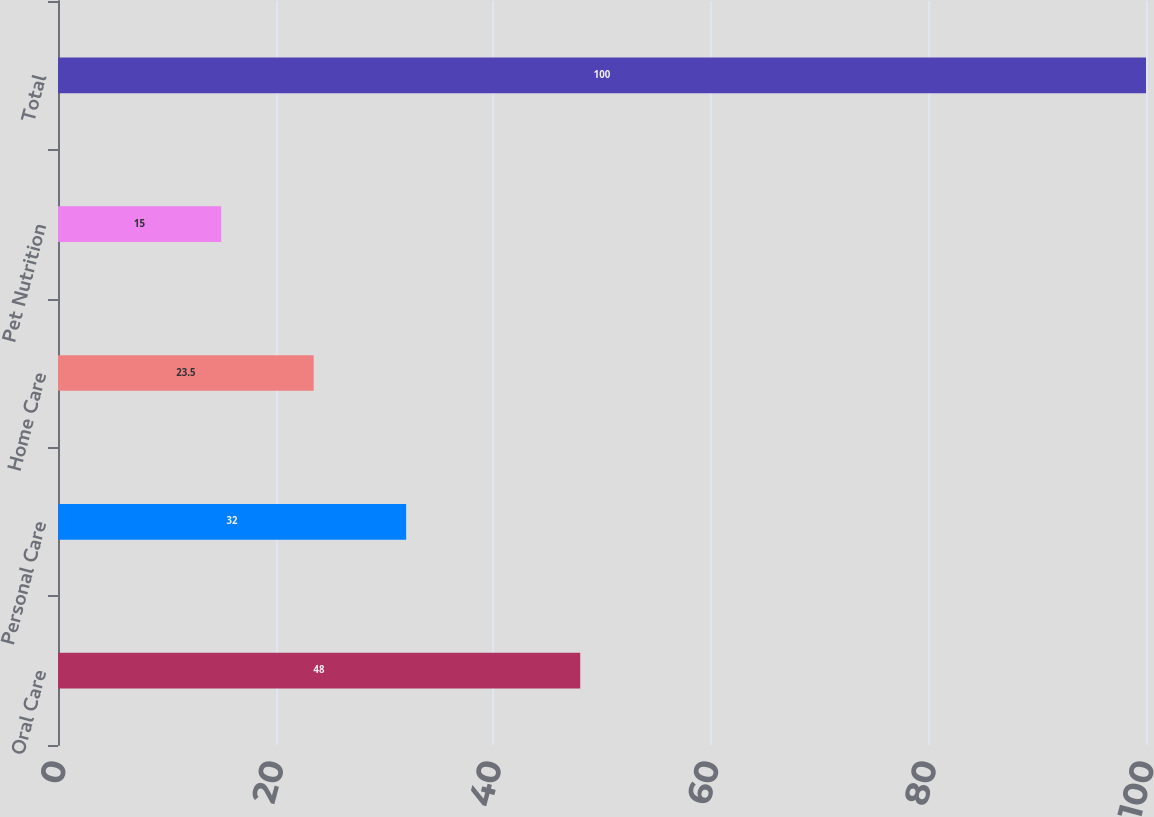Convert chart to OTSL. <chart><loc_0><loc_0><loc_500><loc_500><bar_chart><fcel>Oral Care<fcel>Personal Care<fcel>Home Care<fcel>Pet Nutrition<fcel>Total<nl><fcel>48<fcel>32<fcel>23.5<fcel>15<fcel>100<nl></chart> 